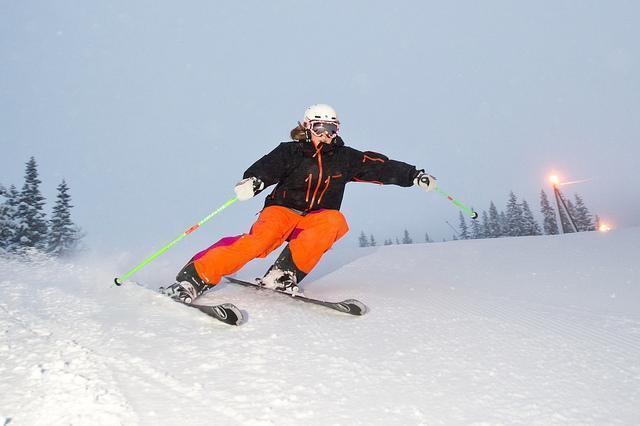How many hospital beds are there?
Give a very brief answer. 0. 